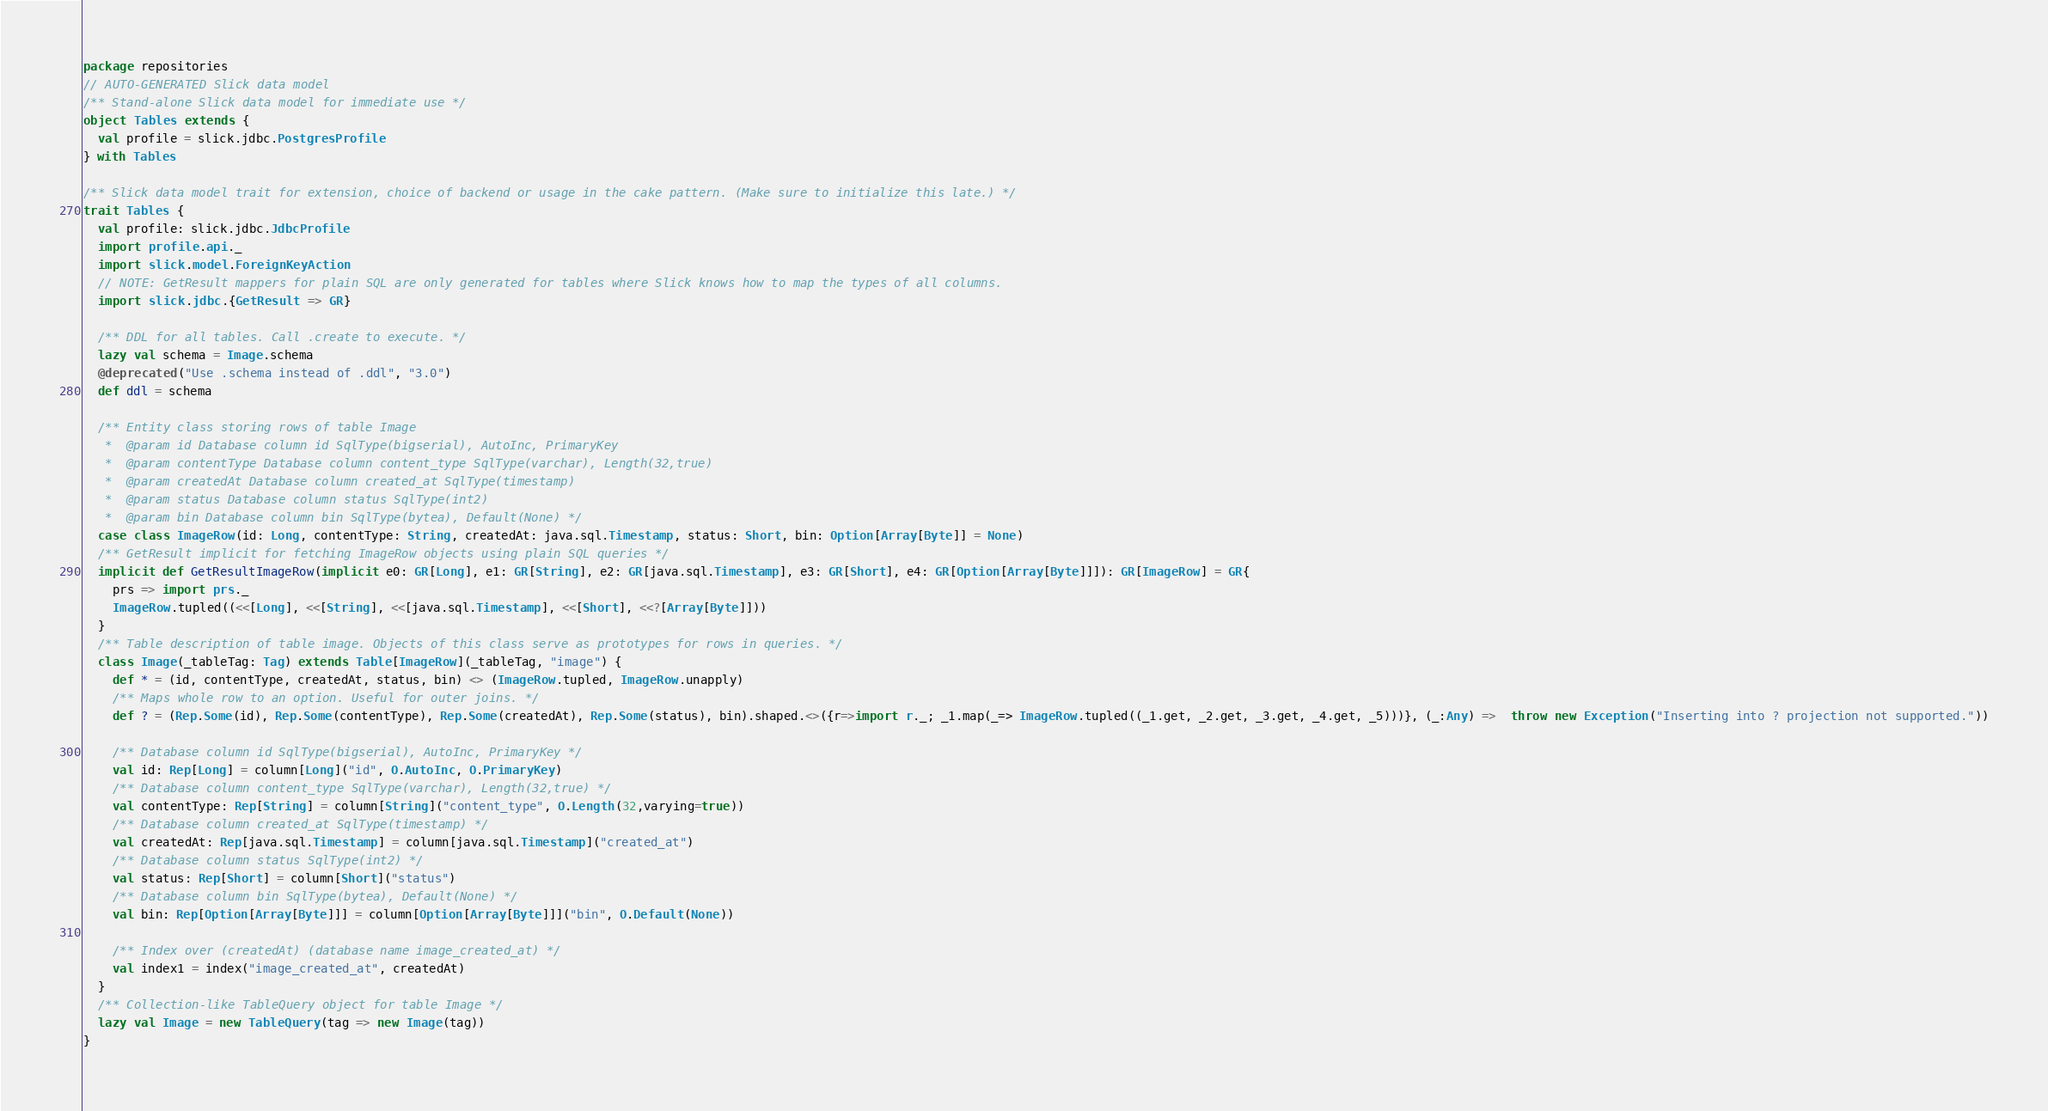<code> <loc_0><loc_0><loc_500><loc_500><_Scala_>package repositories
// AUTO-GENERATED Slick data model
/** Stand-alone Slick data model for immediate use */
object Tables extends {
  val profile = slick.jdbc.PostgresProfile
} with Tables

/** Slick data model trait for extension, choice of backend or usage in the cake pattern. (Make sure to initialize this late.) */
trait Tables {
  val profile: slick.jdbc.JdbcProfile
  import profile.api._
  import slick.model.ForeignKeyAction
  // NOTE: GetResult mappers for plain SQL are only generated for tables where Slick knows how to map the types of all columns.
  import slick.jdbc.{GetResult => GR}

  /** DDL for all tables. Call .create to execute. */
  lazy val schema = Image.schema
  @deprecated("Use .schema instead of .ddl", "3.0")
  def ddl = schema

  /** Entity class storing rows of table Image
   *  @param id Database column id SqlType(bigserial), AutoInc, PrimaryKey
   *  @param contentType Database column content_type SqlType(varchar), Length(32,true)
   *  @param createdAt Database column created_at SqlType(timestamp)
   *  @param status Database column status SqlType(int2)
   *  @param bin Database column bin SqlType(bytea), Default(None) */
  case class ImageRow(id: Long, contentType: String, createdAt: java.sql.Timestamp, status: Short, bin: Option[Array[Byte]] = None)
  /** GetResult implicit for fetching ImageRow objects using plain SQL queries */
  implicit def GetResultImageRow(implicit e0: GR[Long], e1: GR[String], e2: GR[java.sql.Timestamp], e3: GR[Short], e4: GR[Option[Array[Byte]]]): GR[ImageRow] = GR{
    prs => import prs._
    ImageRow.tupled((<<[Long], <<[String], <<[java.sql.Timestamp], <<[Short], <<?[Array[Byte]]))
  }
  /** Table description of table image. Objects of this class serve as prototypes for rows in queries. */
  class Image(_tableTag: Tag) extends Table[ImageRow](_tableTag, "image") {
    def * = (id, contentType, createdAt, status, bin) <> (ImageRow.tupled, ImageRow.unapply)
    /** Maps whole row to an option. Useful for outer joins. */
    def ? = (Rep.Some(id), Rep.Some(contentType), Rep.Some(createdAt), Rep.Some(status), bin).shaped.<>({r=>import r._; _1.map(_=> ImageRow.tupled((_1.get, _2.get, _3.get, _4.get, _5)))}, (_:Any) =>  throw new Exception("Inserting into ? projection not supported."))

    /** Database column id SqlType(bigserial), AutoInc, PrimaryKey */
    val id: Rep[Long] = column[Long]("id", O.AutoInc, O.PrimaryKey)
    /** Database column content_type SqlType(varchar), Length(32,true) */
    val contentType: Rep[String] = column[String]("content_type", O.Length(32,varying=true))
    /** Database column created_at SqlType(timestamp) */
    val createdAt: Rep[java.sql.Timestamp] = column[java.sql.Timestamp]("created_at")
    /** Database column status SqlType(int2) */
    val status: Rep[Short] = column[Short]("status")
    /** Database column bin SqlType(bytea), Default(None) */
    val bin: Rep[Option[Array[Byte]]] = column[Option[Array[Byte]]]("bin", O.Default(None))

    /** Index over (createdAt) (database name image_created_at) */
    val index1 = index("image_created_at", createdAt)
  }
  /** Collection-like TableQuery object for table Image */
  lazy val Image = new TableQuery(tag => new Image(tag))
}
</code> 